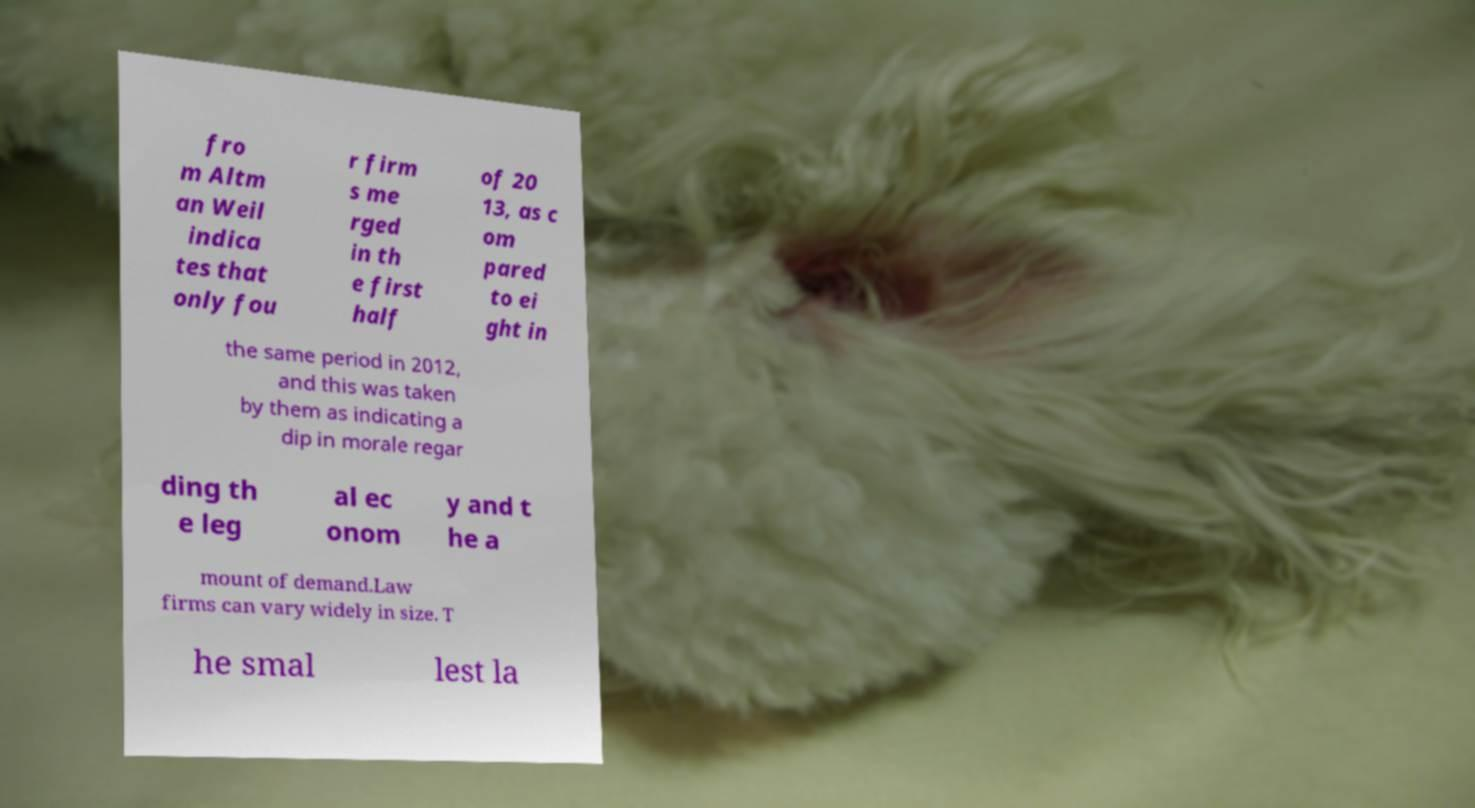Please identify and transcribe the text found in this image. fro m Altm an Weil indica tes that only fou r firm s me rged in th e first half of 20 13, as c om pared to ei ght in the same period in 2012, and this was taken by them as indicating a dip in morale regar ding th e leg al ec onom y and t he a mount of demand.Law firms can vary widely in size. T he smal lest la 